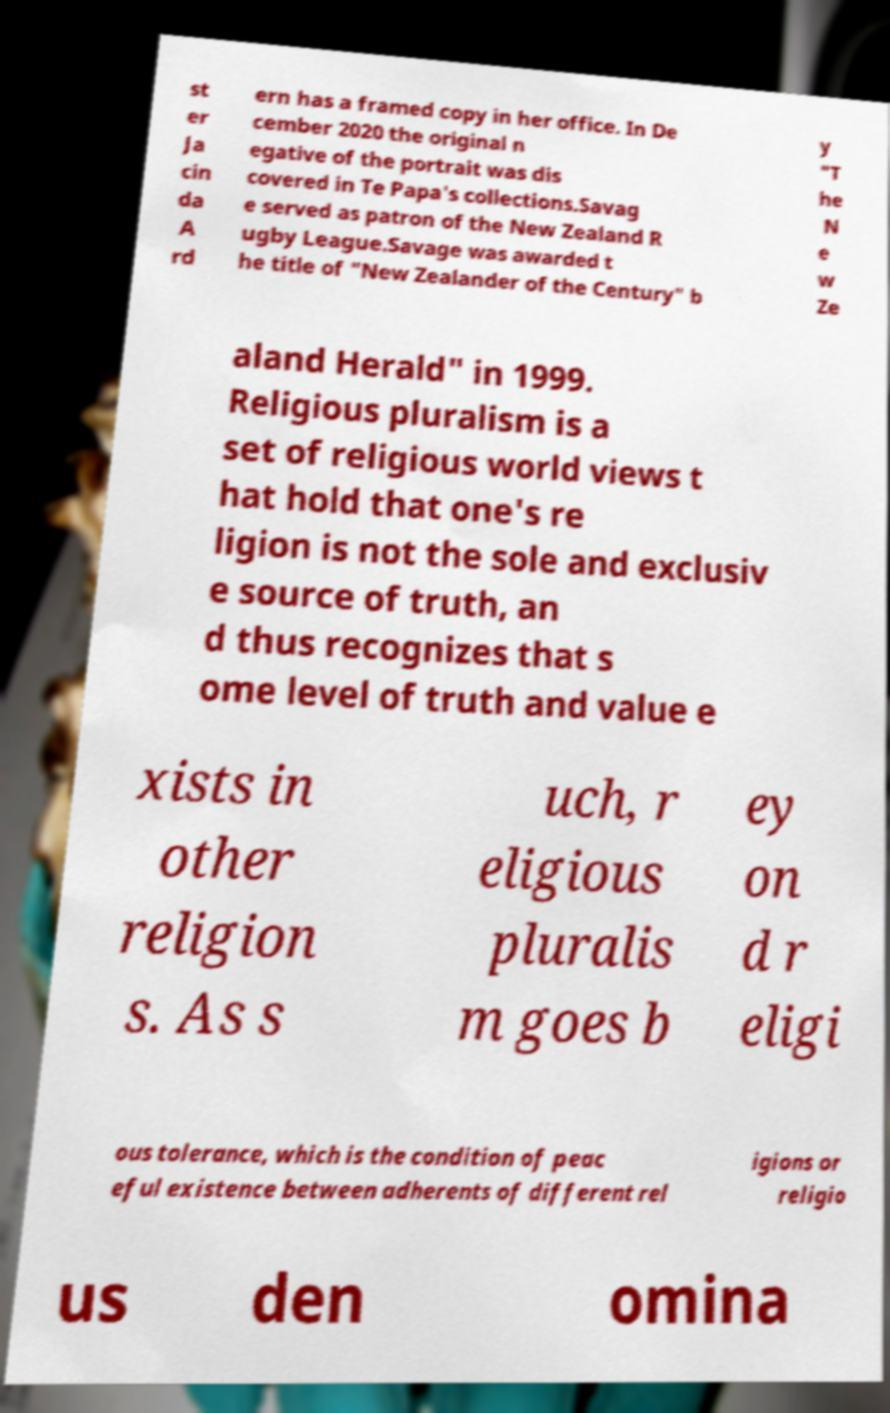Please read and relay the text visible in this image. What does it say? st er Ja cin da A rd ern has a framed copy in her office. In De cember 2020 the original n egative of the portrait was dis covered in Te Papa's collections.Savag e served as patron of the New Zealand R ugby League.Savage was awarded t he title of "New Zealander of the Century" b y "T he N e w Ze aland Herald" in 1999. Religious pluralism is a set of religious world views t hat hold that one's re ligion is not the sole and exclusiv e source of truth, an d thus recognizes that s ome level of truth and value e xists in other religion s. As s uch, r eligious pluralis m goes b ey on d r eligi ous tolerance, which is the condition of peac eful existence between adherents of different rel igions or religio us den omina 